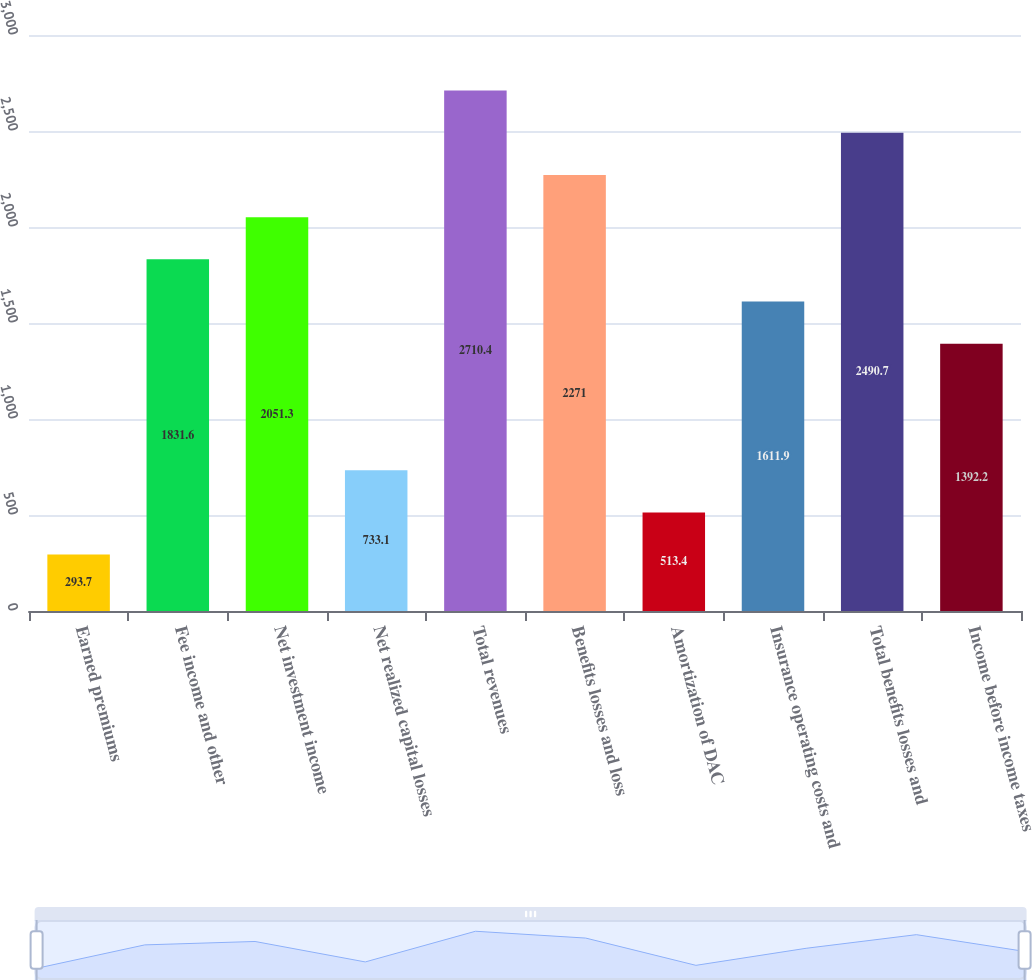<chart> <loc_0><loc_0><loc_500><loc_500><bar_chart><fcel>Earned premiums<fcel>Fee income and other<fcel>Net investment income<fcel>Net realized capital losses<fcel>Total revenues<fcel>Benefits losses and loss<fcel>Amortization of DAC<fcel>Insurance operating costs and<fcel>Total benefits losses and<fcel>Income before income taxes<nl><fcel>293.7<fcel>1831.6<fcel>2051.3<fcel>733.1<fcel>2710.4<fcel>2271<fcel>513.4<fcel>1611.9<fcel>2490.7<fcel>1392.2<nl></chart> 